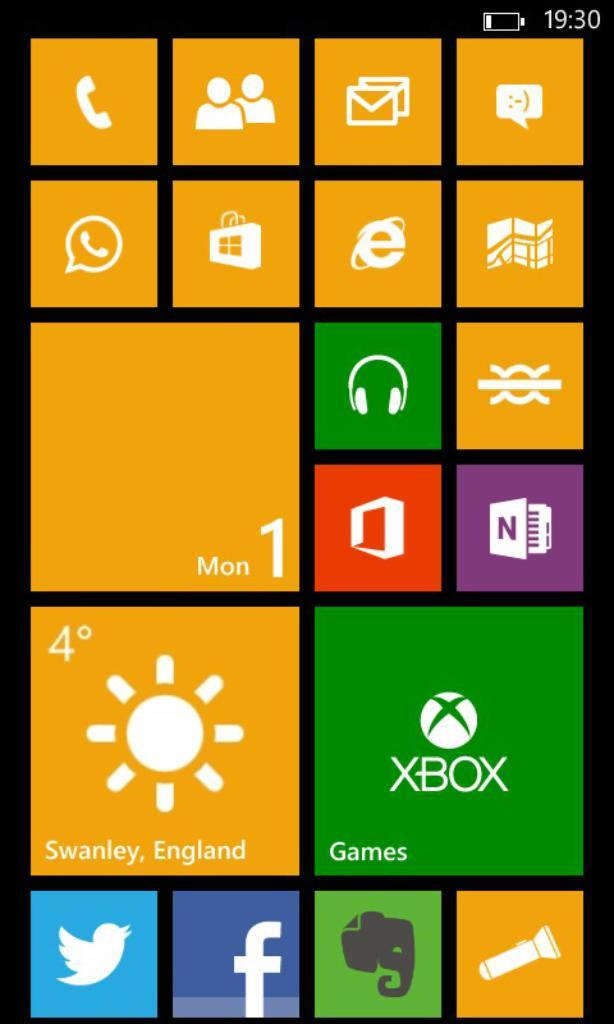Provide a one-sentence caption for the provided image. The menu of an electronic device features a Games option. 